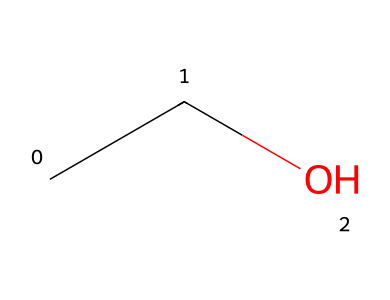What is the name of this chemical? The SMILES representation "CCO" corresponds to ethanol, which is commonly known as ethyl alcohol. The structure indicates a two-carbon chain (C-C) with a hydroxyl group (-OH) attached to the second carbon.
Answer: ethanol How many carbon atoms are in this structure? Looking at the SMILES "CCO," the first two letters 'C' indicate two carbon atoms are present in the molecule. There are no additional carbon atoms indicated in the representation.
Answer: 2 What functional group is present in ethanol? The SMILES "CCO" shows that there is a hydroxyl group (-OH) attached to the carbon chain, which is characteristic of alcohols. This functional group is essential for the chemical's properties.
Answer: hydroxyl group How many total hydrogen atoms are present in ethanol? In the structure represented by "CCO," the first carbon (C) is bonded to three hydrogens (C-H), the second carbon is connected to two hydrogens (C-H), and one hydrogen is connected to the hydroxyl group (OH). Thus, there are 5 hydrogen atoms total (3 + 2 = 5).
Answer: 6 What type of compound is ethanol classified as? Due to the presence of a hydroxyl group and the overall structure, ethanol falls under the classification of alcohols, which are a subtype of organic compounds. The presence of the 'C' and 'O' elements combined with the functional group defines this classification.
Answer: alcohol Is ethanol a saturated or unsaturated hydrocarbon? Ethanol has only single bonds between the carbon atoms, as seen in its SMILES representation "CCO." This means it is classified as a saturated hydrocarbon because it does not contain double or triple bonds between carbon atoms.
Answer: saturated 